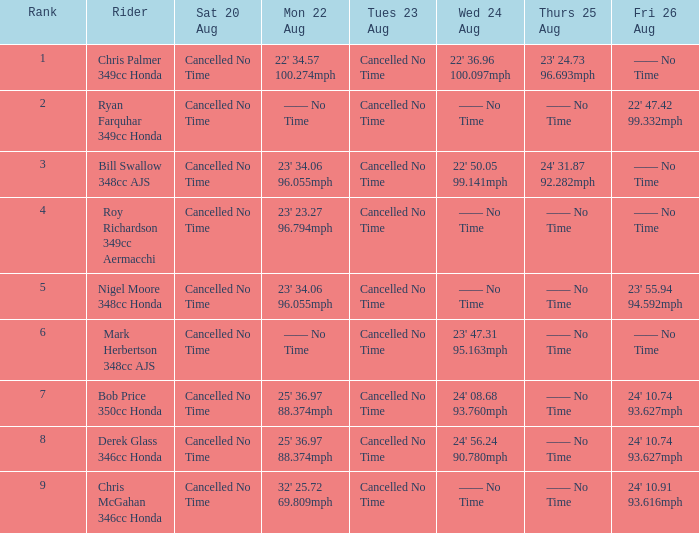What is every value on Thursday August 25 for rank 3? 24' 31.87 92.282mph. 